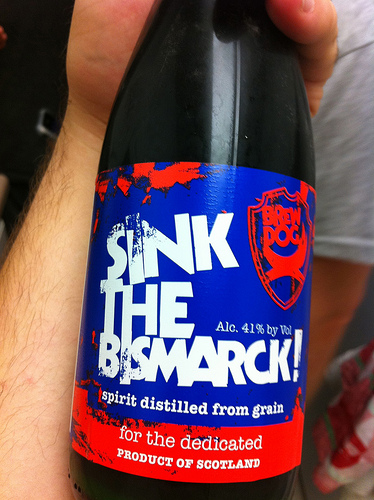<image>
Can you confirm if the label is on the bottle? Yes. Looking at the image, I can see the label is positioned on top of the bottle, with the bottle providing support. 